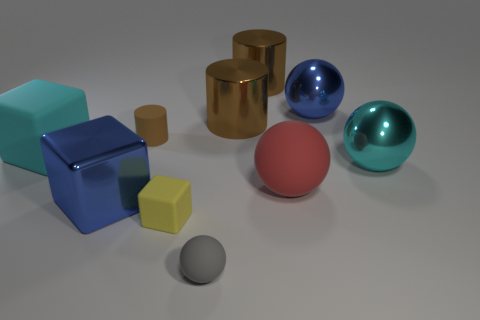The metallic cube is what color?
Your answer should be very brief. Blue. How many tiny gray matte things have the same shape as the cyan metallic object?
Offer a terse response. 1. There is a metallic block that is the same size as the red rubber sphere; what color is it?
Offer a terse response. Blue. Are there any yellow spheres?
Ensure brevity in your answer.  No. The small yellow object that is right of the big cyan rubber thing has what shape?
Give a very brief answer. Cube. What number of large metallic objects are behind the blue metal ball and in front of the big cyan metal thing?
Offer a terse response. 0. Are there any red spheres made of the same material as the gray sphere?
Give a very brief answer. Yes. What number of cubes are either gray things or large things?
Offer a very short reply. 2. The metallic block has what size?
Your answer should be very brief. Large. There is a yellow matte block; what number of big balls are left of it?
Offer a terse response. 0. 